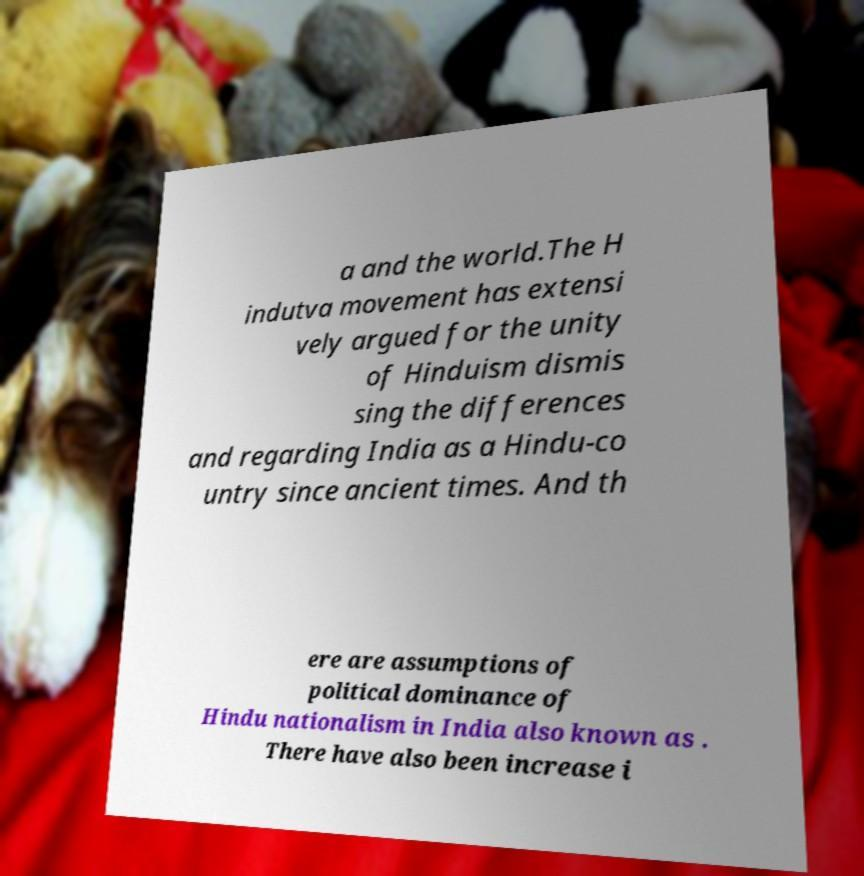There's text embedded in this image that I need extracted. Can you transcribe it verbatim? a and the world.The H indutva movement has extensi vely argued for the unity of Hinduism dismis sing the differences and regarding India as a Hindu-co untry since ancient times. And th ere are assumptions of political dominance of Hindu nationalism in India also known as . There have also been increase i 